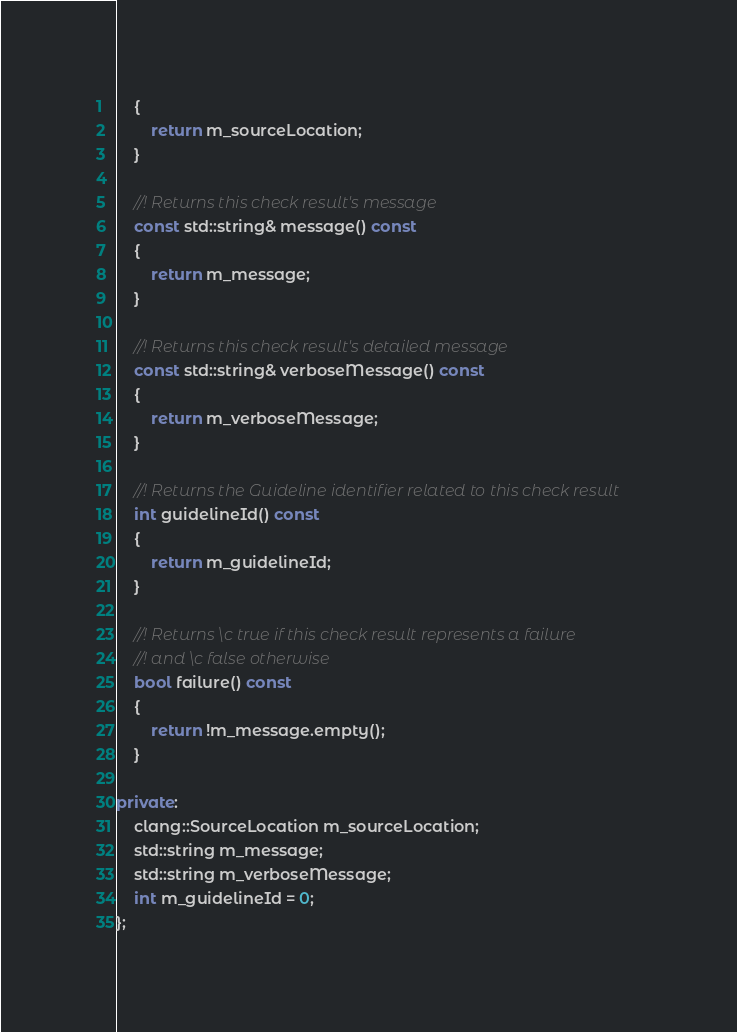<code> <loc_0><loc_0><loc_500><loc_500><_C++_>    {
        return m_sourceLocation;
    }

    //! Returns this check result's message
    const std::string& message() const
    {
        return m_message;
    }

    //! Returns this check result's detailed message
    const std::string& verboseMessage() const
    {
        return m_verboseMessage;
    }

    //! Returns the Guideline identifier related to this check result
    int guidelineId() const
    {
        return m_guidelineId;
    }

    //! Returns \c true if this check result represents a failure
    //! and \c false otherwise
    bool failure() const
    {
        return !m_message.empty();
    }

private:
    clang::SourceLocation m_sourceLocation;
    std::string m_message;
    std::string m_verboseMessage;
    int m_guidelineId = 0;
};
</code> 